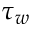Convert formula to latex. <formula><loc_0><loc_0><loc_500><loc_500>\tau _ { w }</formula> 